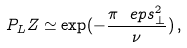<formula> <loc_0><loc_0><loc_500><loc_500>P _ { L } Z \simeq \exp ( - \frac { \pi \ e p s _ { \bot } ^ { 2 } } { \nu } ) \, ,</formula> 